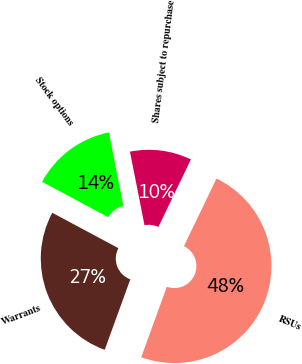<chart> <loc_0><loc_0><loc_500><loc_500><pie_chart><fcel>RSUs<fcel>Warrants<fcel>Stock options<fcel>Shares subject to repurchase<nl><fcel>48.4%<fcel>27.28%<fcel>14.07%<fcel>10.25%<nl></chart> 